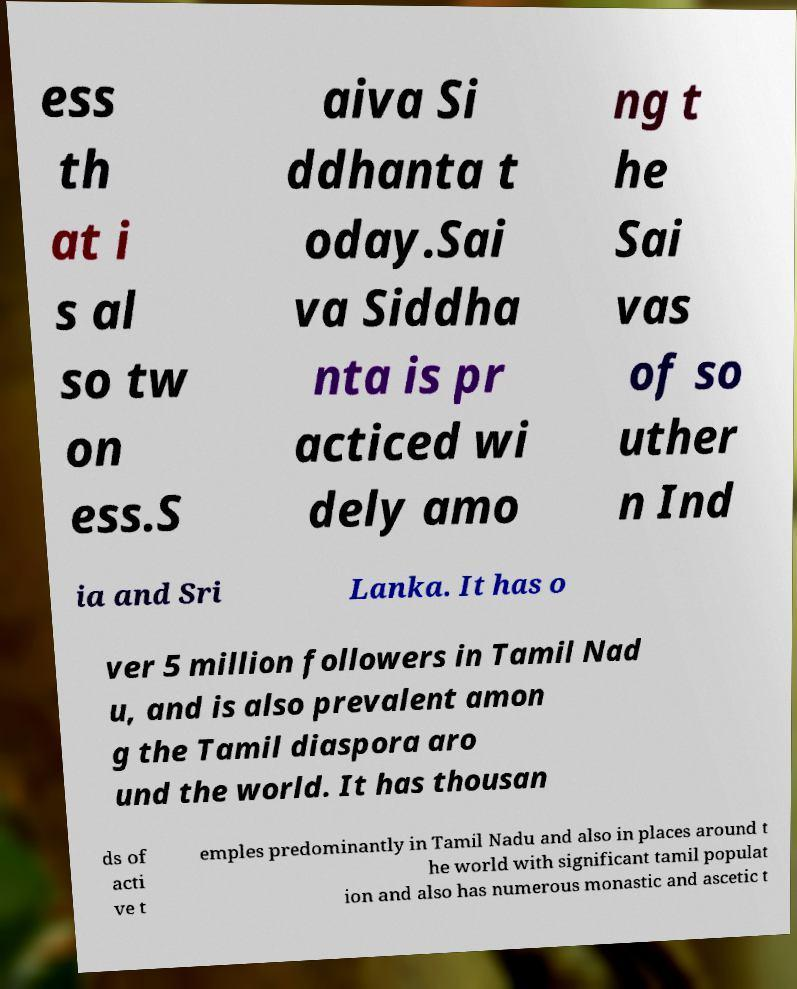For documentation purposes, I need the text within this image transcribed. Could you provide that? ess th at i s al so tw on ess.S aiva Si ddhanta t oday.Sai va Siddha nta is pr acticed wi dely amo ng t he Sai vas of so uther n Ind ia and Sri Lanka. It has o ver 5 million followers in Tamil Nad u, and is also prevalent amon g the Tamil diaspora aro und the world. It has thousan ds of acti ve t emples predominantly in Tamil Nadu and also in places around t he world with significant tamil populat ion and also has numerous monastic and ascetic t 